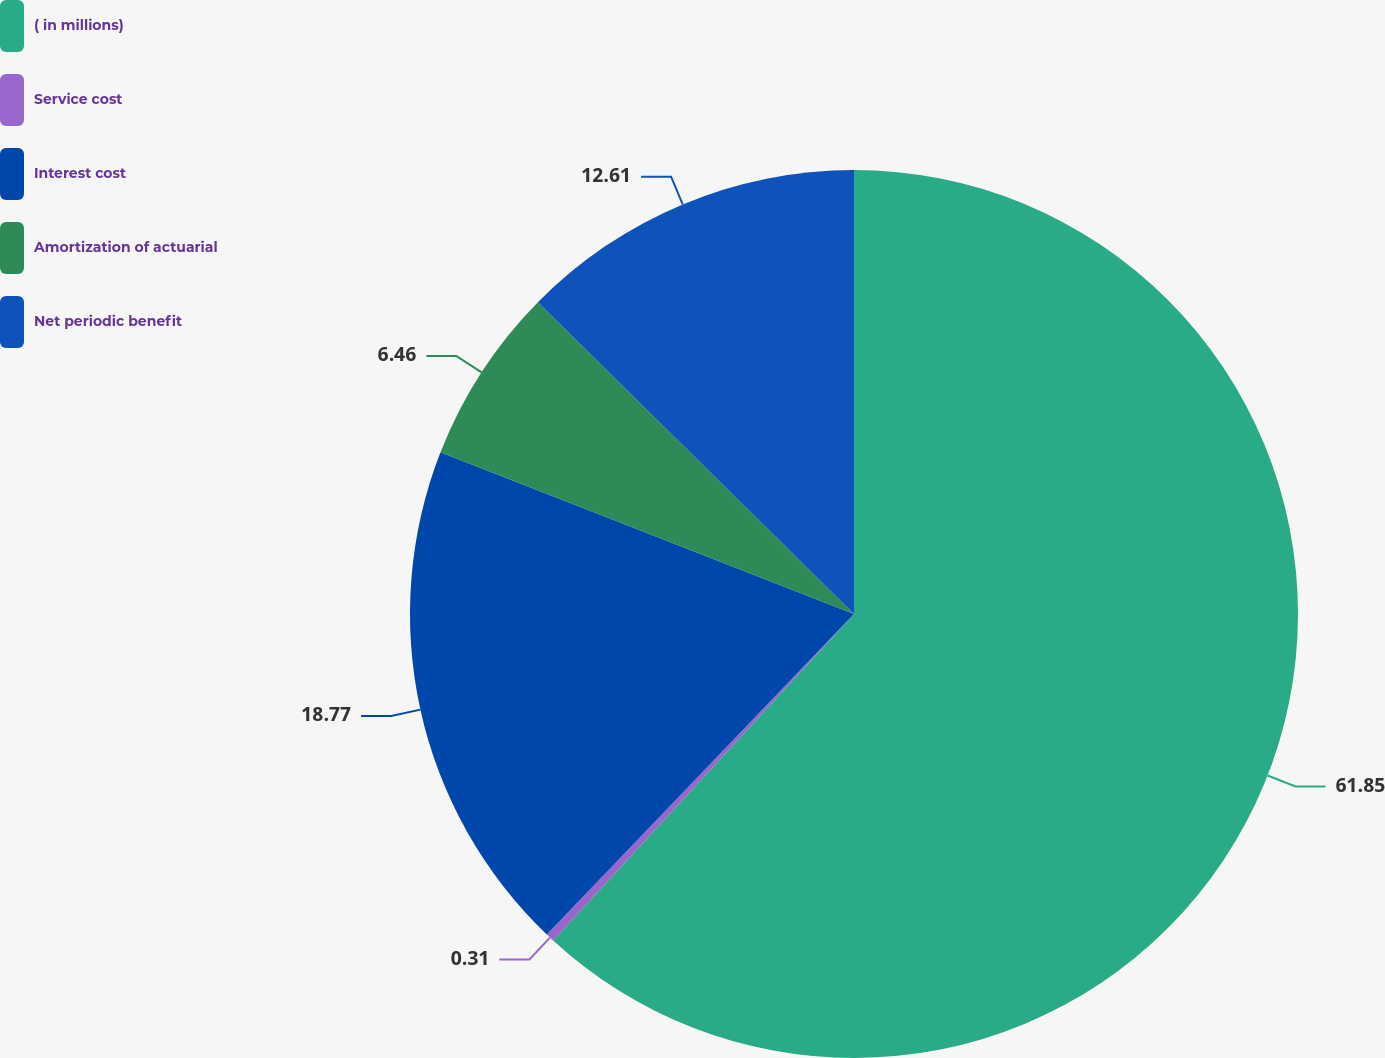Convert chart to OTSL. <chart><loc_0><loc_0><loc_500><loc_500><pie_chart><fcel>( in millions)<fcel>Service cost<fcel>Interest cost<fcel>Amortization of actuarial<fcel>Net periodic benefit<nl><fcel>61.85%<fcel>0.31%<fcel>18.77%<fcel>6.46%<fcel>12.61%<nl></chart> 